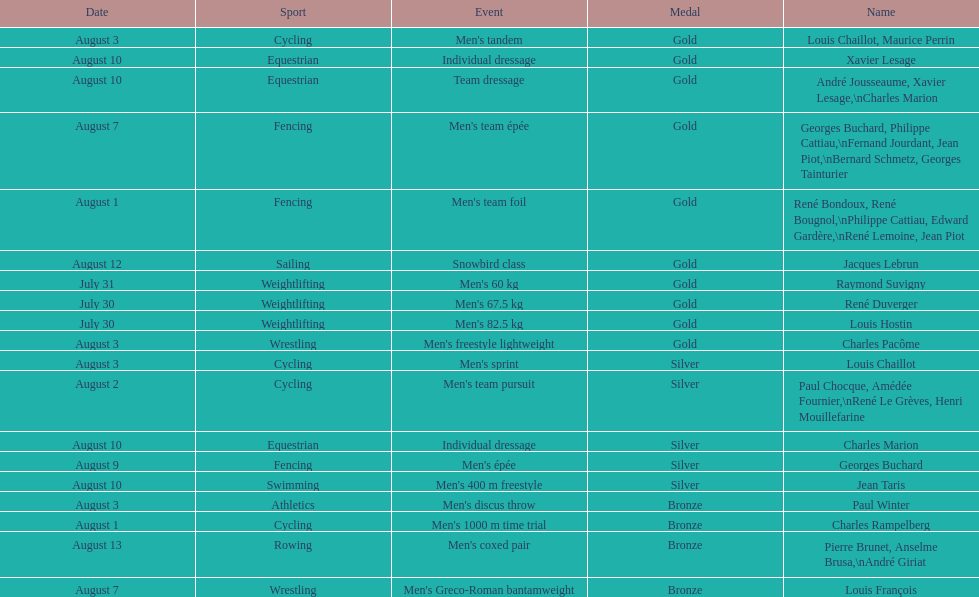What sport did louis challiot win the same medal as paul chocque in? Cycling. 